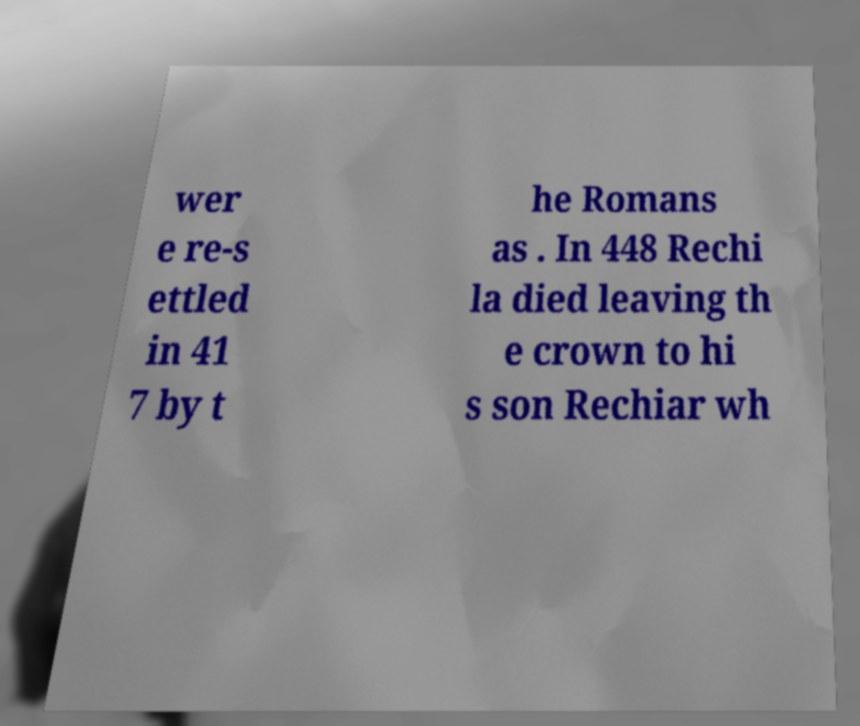I need the written content from this picture converted into text. Can you do that? wer e re-s ettled in 41 7 by t he Romans as . In 448 Rechi la died leaving th e crown to hi s son Rechiar wh 